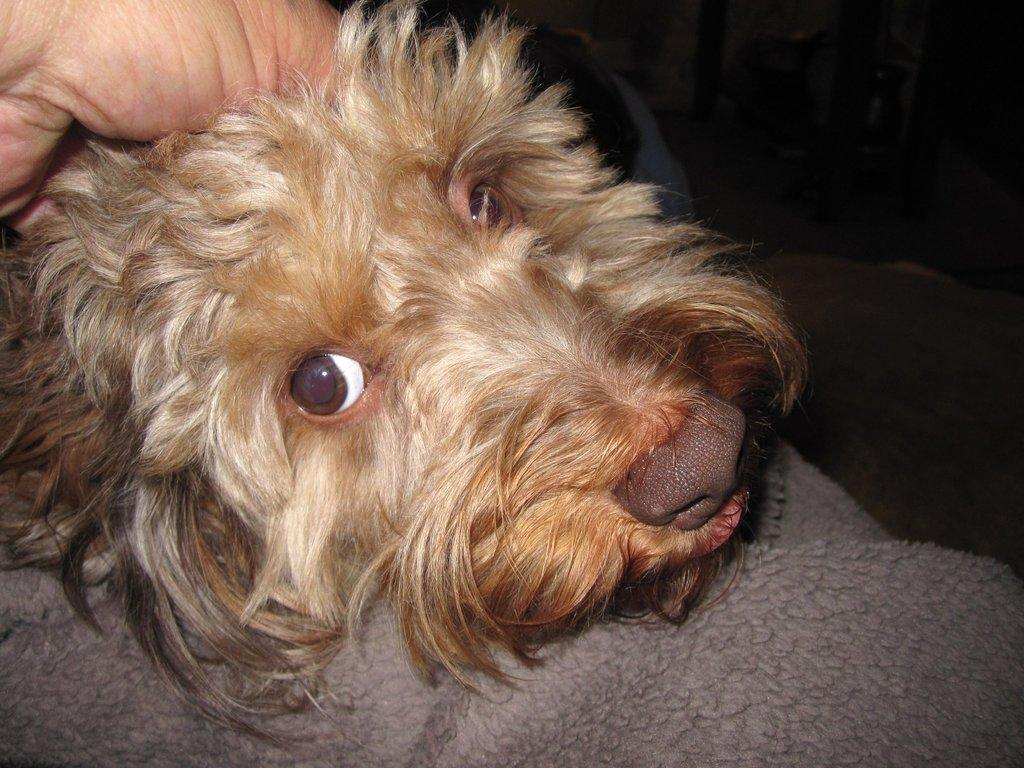What type of animal is in the image? There is a brown color dog in the image. Can you describe any other details about the dog? Unfortunately, the provided facts do not mention any other details about the dog. What else can be seen in the image besides the dog? A hand is visible in the top left corner of the image. How many girls are swimming in the ocean in the image? There are no girls or ocean present in the image; it features a brown color dog and a hand. Is there a guide leading a group of people in the image? There is no guide or group of people present in the image; it features a brown color dog and a hand. 